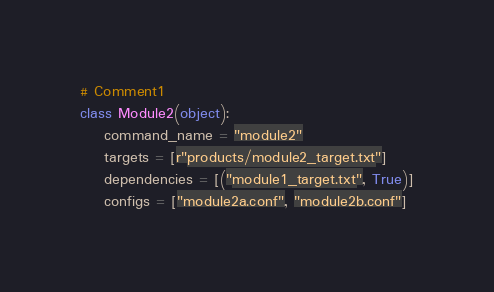Convert code to text. <code><loc_0><loc_0><loc_500><loc_500><_Python_># Comment1
class Module2(object):
    command_name = "module2"
    targets = [r"products/module2_target.txt"]
    dependencies = [("module1_target.txt", True)]
    configs = ["module2a.conf", "module2b.conf"]
</code> 